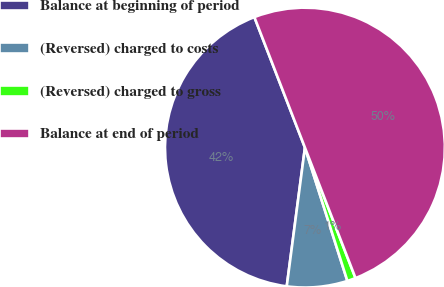<chart> <loc_0><loc_0><loc_500><loc_500><pie_chart><fcel>Balance at beginning of period<fcel>(Reversed) charged to costs<fcel>(Reversed) charged to gross<fcel>Balance at end of period<nl><fcel>42.04%<fcel>6.98%<fcel>0.98%<fcel>50.0%<nl></chart> 